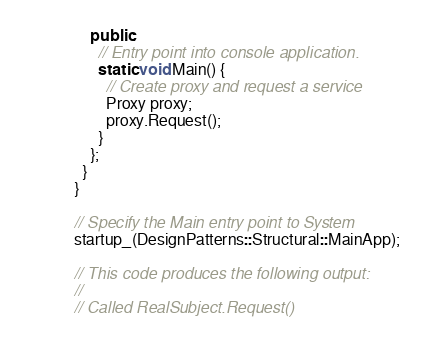Convert code to text. <code><loc_0><loc_0><loc_500><loc_500><_C++_>    public:
      // Entry point into console application.
      static void Main() {
        // Create proxy and request a service
        Proxy proxy;
        proxy.Request();
      }
    };
  }
}

// Specify the Main entry point to System
startup_(DesignPatterns::Structural::MainApp);

// This code produces the following output:
//
// Called RealSubject.Request()
</code> 